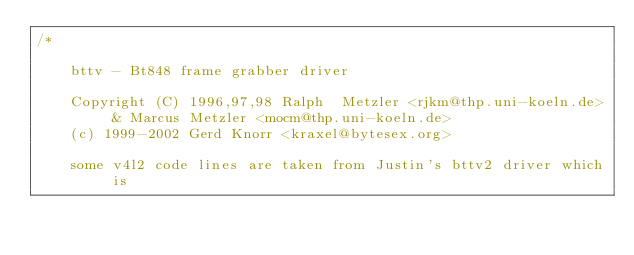<code> <loc_0><loc_0><loc_500><loc_500><_C_>/*

    bttv - Bt848 frame grabber driver

    Copyright (C) 1996,97,98 Ralph  Metzler <rjkm@thp.uni-koeln.de>
			   & Marcus Metzler <mocm@thp.uni-koeln.de>
    (c) 1999-2002 Gerd Knorr <kraxel@bytesex.org>

    some v4l2 code lines are taken from Justin's bttv2 driver which is</code> 